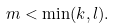Convert formula to latex. <formula><loc_0><loc_0><loc_500><loc_500>m < \min ( k , l ) .</formula> 